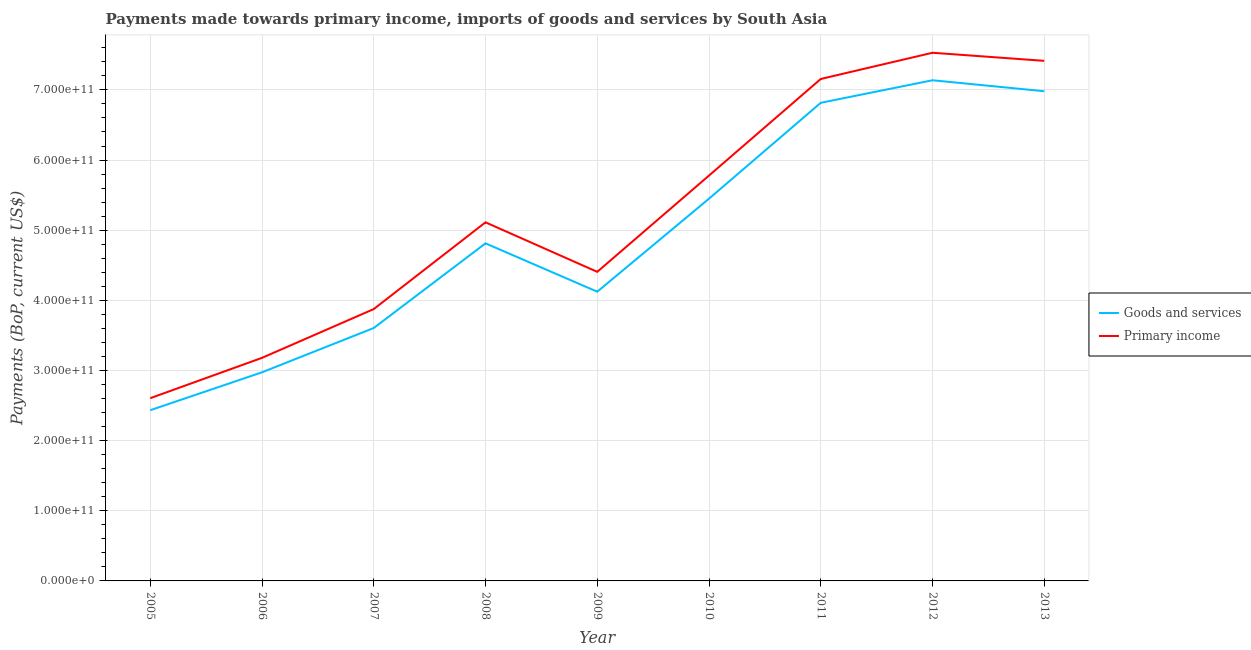How many different coloured lines are there?
Ensure brevity in your answer.  2. Does the line corresponding to payments made towards primary income intersect with the line corresponding to payments made towards goods and services?
Ensure brevity in your answer.  No. Is the number of lines equal to the number of legend labels?
Keep it short and to the point. Yes. What is the payments made towards primary income in 2012?
Your response must be concise. 7.53e+11. Across all years, what is the maximum payments made towards goods and services?
Offer a very short reply. 7.14e+11. Across all years, what is the minimum payments made towards goods and services?
Your answer should be compact. 2.43e+11. In which year was the payments made towards goods and services maximum?
Make the answer very short. 2012. What is the total payments made towards goods and services in the graph?
Keep it short and to the point. 4.43e+12. What is the difference between the payments made towards goods and services in 2009 and that in 2012?
Give a very brief answer. -3.01e+11. What is the difference between the payments made towards primary income in 2013 and the payments made towards goods and services in 2007?
Make the answer very short. 3.81e+11. What is the average payments made towards goods and services per year?
Offer a very short reply. 4.93e+11. In the year 2008, what is the difference between the payments made towards primary income and payments made towards goods and services?
Keep it short and to the point. 3.00e+1. What is the ratio of the payments made towards primary income in 2008 to that in 2009?
Offer a terse response. 1.16. Is the payments made towards primary income in 2006 less than that in 2010?
Give a very brief answer. Yes. Is the difference between the payments made towards goods and services in 2006 and 2008 greater than the difference between the payments made towards primary income in 2006 and 2008?
Keep it short and to the point. Yes. What is the difference between the highest and the second highest payments made towards primary income?
Your answer should be compact. 1.15e+1. What is the difference between the highest and the lowest payments made towards primary income?
Give a very brief answer. 4.92e+11. In how many years, is the payments made towards goods and services greater than the average payments made towards goods and services taken over all years?
Provide a succinct answer. 4. Does the payments made towards primary income monotonically increase over the years?
Provide a succinct answer. No. Is the payments made towards goods and services strictly greater than the payments made towards primary income over the years?
Provide a succinct answer. No. How many lines are there?
Your answer should be compact. 2. How many years are there in the graph?
Provide a short and direct response. 9. What is the difference between two consecutive major ticks on the Y-axis?
Make the answer very short. 1.00e+11. Are the values on the major ticks of Y-axis written in scientific E-notation?
Give a very brief answer. Yes. Does the graph contain any zero values?
Make the answer very short. No. Where does the legend appear in the graph?
Your answer should be compact. Center right. How are the legend labels stacked?
Your answer should be compact. Vertical. What is the title of the graph?
Your answer should be compact. Payments made towards primary income, imports of goods and services by South Asia. What is the label or title of the X-axis?
Give a very brief answer. Year. What is the label or title of the Y-axis?
Provide a succinct answer. Payments (BoP, current US$). What is the Payments (BoP, current US$) of Goods and services in 2005?
Make the answer very short. 2.43e+11. What is the Payments (BoP, current US$) in Primary income in 2005?
Ensure brevity in your answer.  2.61e+11. What is the Payments (BoP, current US$) of Goods and services in 2006?
Provide a short and direct response. 2.97e+11. What is the Payments (BoP, current US$) in Primary income in 2006?
Your answer should be very brief. 3.18e+11. What is the Payments (BoP, current US$) in Goods and services in 2007?
Ensure brevity in your answer.  3.61e+11. What is the Payments (BoP, current US$) in Primary income in 2007?
Your response must be concise. 3.88e+11. What is the Payments (BoP, current US$) in Goods and services in 2008?
Your response must be concise. 4.81e+11. What is the Payments (BoP, current US$) in Primary income in 2008?
Provide a succinct answer. 5.11e+11. What is the Payments (BoP, current US$) in Goods and services in 2009?
Your answer should be compact. 4.12e+11. What is the Payments (BoP, current US$) of Primary income in 2009?
Your answer should be very brief. 4.41e+11. What is the Payments (BoP, current US$) of Goods and services in 2010?
Your response must be concise. 5.45e+11. What is the Payments (BoP, current US$) of Primary income in 2010?
Your answer should be very brief. 5.78e+11. What is the Payments (BoP, current US$) in Goods and services in 2011?
Ensure brevity in your answer.  6.82e+11. What is the Payments (BoP, current US$) in Primary income in 2011?
Keep it short and to the point. 7.16e+11. What is the Payments (BoP, current US$) in Goods and services in 2012?
Your answer should be very brief. 7.14e+11. What is the Payments (BoP, current US$) in Primary income in 2012?
Make the answer very short. 7.53e+11. What is the Payments (BoP, current US$) of Goods and services in 2013?
Ensure brevity in your answer.  6.98e+11. What is the Payments (BoP, current US$) of Primary income in 2013?
Your answer should be very brief. 7.41e+11. Across all years, what is the maximum Payments (BoP, current US$) in Goods and services?
Provide a succinct answer. 7.14e+11. Across all years, what is the maximum Payments (BoP, current US$) of Primary income?
Provide a succinct answer. 7.53e+11. Across all years, what is the minimum Payments (BoP, current US$) in Goods and services?
Make the answer very short. 2.43e+11. Across all years, what is the minimum Payments (BoP, current US$) of Primary income?
Give a very brief answer. 2.61e+11. What is the total Payments (BoP, current US$) of Goods and services in the graph?
Your answer should be very brief. 4.43e+12. What is the total Payments (BoP, current US$) in Primary income in the graph?
Make the answer very short. 4.71e+12. What is the difference between the Payments (BoP, current US$) in Goods and services in 2005 and that in 2006?
Ensure brevity in your answer.  -5.40e+1. What is the difference between the Payments (BoP, current US$) of Primary income in 2005 and that in 2006?
Make the answer very short. -5.75e+1. What is the difference between the Payments (BoP, current US$) of Goods and services in 2005 and that in 2007?
Your answer should be compact. -1.17e+11. What is the difference between the Payments (BoP, current US$) of Primary income in 2005 and that in 2007?
Provide a short and direct response. -1.27e+11. What is the difference between the Payments (BoP, current US$) of Goods and services in 2005 and that in 2008?
Your answer should be very brief. -2.38e+11. What is the difference between the Payments (BoP, current US$) in Primary income in 2005 and that in 2008?
Your answer should be very brief. -2.51e+11. What is the difference between the Payments (BoP, current US$) in Goods and services in 2005 and that in 2009?
Make the answer very short. -1.69e+11. What is the difference between the Payments (BoP, current US$) in Primary income in 2005 and that in 2009?
Provide a succinct answer. -1.80e+11. What is the difference between the Payments (BoP, current US$) in Goods and services in 2005 and that in 2010?
Your answer should be very brief. -3.02e+11. What is the difference between the Payments (BoP, current US$) in Primary income in 2005 and that in 2010?
Your response must be concise. -3.17e+11. What is the difference between the Payments (BoP, current US$) in Goods and services in 2005 and that in 2011?
Your answer should be compact. -4.38e+11. What is the difference between the Payments (BoP, current US$) in Primary income in 2005 and that in 2011?
Provide a short and direct response. -4.55e+11. What is the difference between the Payments (BoP, current US$) in Goods and services in 2005 and that in 2012?
Provide a short and direct response. -4.70e+11. What is the difference between the Payments (BoP, current US$) of Primary income in 2005 and that in 2012?
Your response must be concise. -4.92e+11. What is the difference between the Payments (BoP, current US$) in Goods and services in 2005 and that in 2013?
Provide a succinct answer. -4.55e+11. What is the difference between the Payments (BoP, current US$) of Primary income in 2005 and that in 2013?
Provide a succinct answer. -4.81e+11. What is the difference between the Payments (BoP, current US$) of Goods and services in 2006 and that in 2007?
Your answer should be very brief. -6.32e+1. What is the difference between the Payments (BoP, current US$) of Primary income in 2006 and that in 2007?
Make the answer very short. -6.95e+1. What is the difference between the Payments (BoP, current US$) in Goods and services in 2006 and that in 2008?
Provide a short and direct response. -1.84e+11. What is the difference between the Payments (BoP, current US$) in Primary income in 2006 and that in 2008?
Provide a short and direct response. -1.93e+11. What is the difference between the Payments (BoP, current US$) in Goods and services in 2006 and that in 2009?
Provide a succinct answer. -1.15e+11. What is the difference between the Payments (BoP, current US$) of Primary income in 2006 and that in 2009?
Your answer should be compact. -1.23e+11. What is the difference between the Payments (BoP, current US$) in Goods and services in 2006 and that in 2010?
Your answer should be compact. -2.48e+11. What is the difference between the Payments (BoP, current US$) of Primary income in 2006 and that in 2010?
Give a very brief answer. -2.60e+11. What is the difference between the Payments (BoP, current US$) of Goods and services in 2006 and that in 2011?
Offer a very short reply. -3.84e+11. What is the difference between the Payments (BoP, current US$) in Primary income in 2006 and that in 2011?
Your answer should be very brief. -3.98e+11. What is the difference between the Payments (BoP, current US$) in Goods and services in 2006 and that in 2012?
Provide a succinct answer. -4.16e+11. What is the difference between the Payments (BoP, current US$) of Primary income in 2006 and that in 2012?
Provide a short and direct response. -4.35e+11. What is the difference between the Payments (BoP, current US$) in Goods and services in 2006 and that in 2013?
Make the answer very short. -4.01e+11. What is the difference between the Payments (BoP, current US$) of Primary income in 2006 and that in 2013?
Keep it short and to the point. -4.23e+11. What is the difference between the Payments (BoP, current US$) in Goods and services in 2007 and that in 2008?
Provide a succinct answer. -1.21e+11. What is the difference between the Payments (BoP, current US$) in Primary income in 2007 and that in 2008?
Provide a short and direct response. -1.24e+11. What is the difference between the Payments (BoP, current US$) in Goods and services in 2007 and that in 2009?
Offer a terse response. -5.18e+1. What is the difference between the Payments (BoP, current US$) of Primary income in 2007 and that in 2009?
Ensure brevity in your answer.  -5.31e+1. What is the difference between the Payments (BoP, current US$) in Goods and services in 2007 and that in 2010?
Your response must be concise. -1.84e+11. What is the difference between the Payments (BoP, current US$) in Primary income in 2007 and that in 2010?
Ensure brevity in your answer.  -1.90e+11. What is the difference between the Payments (BoP, current US$) of Goods and services in 2007 and that in 2011?
Provide a short and direct response. -3.21e+11. What is the difference between the Payments (BoP, current US$) in Primary income in 2007 and that in 2011?
Offer a very short reply. -3.28e+11. What is the difference between the Payments (BoP, current US$) of Goods and services in 2007 and that in 2012?
Ensure brevity in your answer.  -3.53e+11. What is the difference between the Payments (BoP, current US$) in Primary income in 2007 and that in 2012?
Make the answer very short. -3.65e+11. What is the difference between the Payments (BoP, current US$) of Goods and services in 2007 and that in 2013?
Ensure brevity in your answer.  -3.38e+11. What is the difference between the Payments (BoP, current US$) in Primary income in 2007 and that in 2013?
Give a very brief answer. -3.54e+11. What is the difference between the Payments (BoP, current US$) in Goods and services in 2008 and that in 2009?
Make the answer very short. 6.89e+1. What is the difference between the Payments (BoP, current US$) in Primary income in 2008 and that in 2009?
Give a very brief answer. 7.06e+1. What is the difference between the Payments (BoP, current US$) in Goods and services in 2008 and that in 2010?
Keep it short and to the point. -6.37e+1. What is the difference between the Payments (BoP, current US$) in Primary income in 2008 and that in 2010?
Offer a terse response. -6.66e+1. What is the difference between the Payments (BoP, current US$) of Goods and services in 2008 and that in 2011?
Your answer should be compact. -2.00e+11. What is the difference between the Payments (BoP, current US$) in Primary income in 2008 and that in 2011?
Give a very brief answer. -2.04e+11. What is the difference between the Payments (BoP, current US$) of Goods and services in 2008 and that in 2012?
Your answer should be very brief. -2.33e+11. What is the difference between the Payments (BoP, current US$) of Primary income in 2008 and that in 2012?
Make the answer very short. -2.42e+11. What is the difference between the Payments (BoP, current US$) of Goods and services in 2008 and that in 2013?
Your response must be concise. -2.17e+11. What is the difference between the Payments (BoP, current US$) of Primary income in 2008 and that in 2013?
Give a very brief answer. -2.30e+11. What is the difference between the Payments (BoP, current US$) in Goods and services in 2009 and that in 2010?
Ensure brevity in your answer.  -1.33e+11. What is the difference between the Payments (BoP, current US$) in Primary income in 2009 and that in 2010?
Your response must be concise. -1.37e+11. What is the difference between the Payments (BoP, current US$) of Goods and services in 2009 and that in 2011?
Your response must be concise. -2.69e+11. What is the difference between the Payments (BoP, current US$) of Primary income in 2009 and that in 2011?
Give a very brief answer. -2.75e+11. What is the difference between the Payments (BoP, current US$) of Goods and services in 2009 and that in 2012?
Provide a short and direct response. -3.01e+11. What is the difference between the Payments (BoP, current US$) of Primary income in 2009 and that in 2012?
Make the answer very short. -3.12e+11. What is the difference between the Payments (BoP, current US$) of Goods and services in 2009 and that in 2013?
Your answer should be very brief. -2.86e+11. What is the difference between the Payments (BoP, current US$) in Primary income in 2009 and that in 2013?
Provide a succinct answer. -3.01e+11. What is the difference between the Payments (BoP, current US$) of Goods and services in 2010 and that in 2011?
Offer a terse response. -1.37e+11. What is the difference between the Payments (BoP, current US$) of Primary income in 2010 and that in 2011?
Offer a very short reply. -1.38e+11. What is the difference between the Payments (BoP, current US$) in Goods and services in 2010 and that in 2012?
Keep it short and to the point. -1.69e+11. What is the difference between the Payments (BoP, current US$) in Primary income in 2010 and that in 2012?
Provide a succinct answer. -1.75e+11. What is the difference between the Payments (BoP, current US$) in Goods and services in 2010 and that in 2013?
Your answer should be very brief. -1.53e+11. What is the difference between the Payments (BoP, current US$) of Primary income in 2010 and that in 2013?
Ensure brevity in your answer.  -1.64e+11. What is the difference between the Payments (BoP, current US$) of Goods and services in 2011 and that in 2012?
Give a very brief answer. -3.21e+1. What is the difference between the Payments (BoP, current US$) in Primary income in 2011 and that in 2012?
Give a very brief answer. -3.74e+1. What is the difference between the Payments (BoP, current US$) in Goods and services in 2011 and that in 2013?
Your response must be concise. -1.65e+1. What is the difference between the Payments (BoP, current US$) of Primary income in 2011 and that in 2013?
Your response must be concise. -2.58e+1. What is the difference between the Payments (BoP, current US$) of Goods and services in 2012 and that in 2013?
Your answer should be compact. 1.56e+1. What is the difference between the Payments (BoP, current US$) in Primary income in 2012 and that in 2013?
Offer a terse response. 1.15e+1. What is the difference between the Payments (BoP, current US$) in Goods and services in 2005 and the Payments (BoP, current US$) in Primary income in 2006?
Provide a succinct answer. -7.46e+1. What is the difference between the Payments (BoP, current US$) of Goods and services in 2005 and the Payments (BoP, current US$) of Primary income in 2007?
Offer a very short reply. -1.44e+11. What is the difference between the Payments (BoP, current US$) of Goods and services in 2005 and the Payments (BoP, current US$) of Primary income in 2008?
Your response must be concise. -2.68e+11. What is the difference between the Payments (BoP, current US$) of Goods and services in 2005 and the Payments (BoP, current US$) of Primary income in 2009?
Offer a very short reply. -1.97e+11. What is the difference between the Payments (BoP, current US$) of Goods and services in 2005 and the Payments (BoP, current US$) of Primary income in 2010?
Provide a succinct answer. -3.34e+11. What is the difference between the Payments (BoP, current US$) in Goods and services in 2005 and the Payments (BoP, current US$) in Primary income in 2011?
Provide a short and direct response. -4.72e+11. What is the difference between the Payments (BoP, current US$) of Goods and services in 2005 and the Payments (BoP, current US$) of Primary income in 2012?
Keep it short and to the point. -5.10e+11. What is the difference between the Payments (BoP, current US$) of Goods and services in 2005 and the Payments (BoP, current US$) of Primary income in 2013?
Provide a succinct answer. -4.98e+11. What is the difference between the Payments (BoP, current US$) in Goods and services in 2006 and the Payments (BoP, current US$) in Primary income in 2007?
Make the answer very short. -9.01e+1. What is the difference between the Payments (BoP, current US$) in Goods and services in 2006 and the Payments (BoP, current US$) in Primary income in 2008?
Provide a short and direct response. -2.14e+11. What is the difference between the Payments (BoP, current US$) of Goods and services in 2006 and the Payments (BoP, current US$) of Primary income in 2009?
Offer a terse response. -1.43e+11. What is the difference between the Payments (BoP, current US$) of Goods and services in 2006 and the Payments (BoP, current US$) of Primary income in 2010?
Make the answer very short. -2.80e+11. What is the difference between the Payments (BoP, current US$) of Goods and services in 2006 and the Payments (BoP, current US$) of Primary income in 2011?
Ensure brevity in your answer.  -4.18e+11. What is the difference between the Payments (BoP, current US$) in Goods and services in 2006 and the Payments (BoP, current US$) in Primary income in 2012?
Ensure brevity in your answer.  -4.56e+11. What is the difference between the Payments (BoP, current US$) of Goods and services in 2006 and the Payments (BoP, current US$) of Primary income in 2013?
Provide a succinct answer. -4.44e+11. What is the difference between the Payments (BoP, current US$) in Goods and services in 2007 and the Payments (BoP, current US$) in Primary income in 2008?
Your response must be concise. -1.51e+11. What is the difference between the Payments (BoP, current US$) in Goods and services in 2007 and the Payments (BoP, current US$) in Primary income in 2009?
Offer a very short reply. -8.01e+1. What is the difference between the Payments (BoP, current US$) in Goods and services in 2007 and the Payments (BoP, current US$) in Primary income in 2010?
Provide a short and direct response. -2.17e+11. What is the difference between the Payments (BoP, current US$) of Goods and services in 2007 and the Payments (BoP, current US$) of Primary income in 2011?
Make the answer very short. -3.55e+11. What is the difference between the Payments (BoP, current US$) of Goods and services in 2007 and the Payments (BoP, current US$) of Primary income in 2012?
Provide a succinct answer. -3.92e+11. What is the difference between the Payments (BoP, current US$) of Goods and services in 2007 and the Payments (BoP, current US$) of Primary income in 2013?
Make the answer very short. -3.81e+11. What is the difference between the Payments (BoP, current US$) in Goods and services in 2008 and the Payments (BoP, current US$) in Primary income in 2009?
Your response must be concise. 4.06e+1. What is the difference between the Payments (BoP, current US$) in Goods and services in 2008 and the Payments (BoP, current US$) in Primary income in 2010?
Your response must be concise. -9.66e+1. What is the difference between the Payments (BoP, current US$) in Goods and services in 2008 and the Payments (BoP, current US$) in Primary income in 2011?
Provide a succinct answer. -2.34e+11. What is the difference between the Payments (BoP, current US$) of Goods and services in 2008 and the Payments (BoP, current US$) of Primary income in 2012?
Your response must be concise. -2.72e+11. What is the difference between the Payments (BoP, current US$) of Goods and services in 2008 and the Payments (BoP, current US$) of Primary income in 2013?
Make the answer very short. -2.60e+11. What is the difference between the Payments (BoP, current US$) in Goods and services in 2009 and the Payments (BoP, current US$) in Primary income in 2010?
Your answer should be compact. -1.66e+11. What is the difference between the Payments (BoP, current US$) of Goods and services in 2009 and the Payments (BoP, current US$) of Primary income in 2011?
Your response must be concise. -3.03e+11. What is the difference between the Payments (BoP, current US$) of Goods and services in 2009 and the Payments (BoP, current US$) of Primary income in 2012?
Your answer should be very brief. -3.41e+11. What is the difference between the Payments (BoP, current US$) in Goods and services in 2009 and the Payments (BoP, current US$) in Primary income in 2013?
Offer a very short reply. -3.29e+11. What is the difference between the Payments (BoP, current US$) in Goods and services in 2010 and the Payments (BoP, current US$) in Primary income in 2011?
Ensure brevity in your answer.  -1.71e+11. What is the difference between the Payments (BoP, current US$) of Goods and services in 2010 and the Payments (BoP, current US$) of Primary income in 2012?
Your answer should be very brief. -2.08e+11. What is the difference between the Payments (BoP, current US$) of Goods and services in 2010 and the Payments (BoP, current US$) of Primary income in 2013?
Your answer should be very brief. -1.96e+11. What is the difference between the Payments (BoP, current US$) in Goods and services in 2011 and the Payments (BoP, current US$) in Primary income in 2012?
Offer a terse response. -7.14e+1. What is the difference between the Payments (BoP, current US$) in Goods and services in 2011 and the Payments (BoP, current US$) in Primary income in 2013?
Provide a short and direct response. -5.98e+1. What is the difference between the Payments (BoP, current US$) in Goods and services in 2012 and the Payments (BoP, current US$) in Primary income in 2013?
Your answer should be very brief. -2.77e+1. What is the average Payments (BoP, current US$) in Goods and services per year?
Give a very brief answer. 4.93e+11. What is the average Payments (BoP, current US$) of Primary income per year?
Give a very brief answer. 5.23e+11. In the year 2005, what is the difference between the Payments (BoP, current US$) in Goods and services and Payments (BoP, current US$) in Primary income?
Ensure brevity in your answer.  -1.71e+1. In the year 2006, what is the difference between the Payments (BoP, current US$) in Goods and services and Payments (BoP, current US$) in Primary income?
Provide a succinct answer. -2.06e+1. In the year 2007, what is the difference between the Payments (BoP, current US$) of Goods and services and Payments (BoP, current US$) of Primary income?
Your response must be concise. -2.70e+1. In the year 2008, what is the difference between the Payments (BoP, current US$) of Goods and services and Payments (BoP, current US$) of Primary income?
Your response must be concise. -3.00e+1. In the year 2009, what is the difference between the Payments (BoP, current US$) of Goods and services and Payments (BoP, current US$) of Primary income?
Give a very brief answer. -2.83e+1. In the year 2010, what is the difference between the Payments (BoP, current US$) in Goods and services and Payments (BoP, current US$) in Primary income?
Make the answer very short. -3.30e+1. In the year 2011, what is the difference between the Payments (BoP, current US$) of Goods and services and Payments (BoP, current US$) of Primary income?
Your response must be concise. -3.40e+1. In the year 2012, what is the difference between the Payments (BoP, current US$) of Goods and services and Payments (BoP, current US$) of Primary income?
Provide a succinct answer. -3.92e+1. In the year 2013, what is the difference between the Payments (BoP, current US$) in Goods and services and Payments (BoP, current US$) in Primary income?
Give a very brief answer. -4.33e+1. What is the ratio of the Payments (BoP, current US$) of Goods and services in 2005 to that in 2006?
Give a very brief answer. 0.82. What is the ratio of the Payments (BoP, current US$) in Primary income in 2005 to that in 2006?
Your answer should be compact. 0.82. What is the ratio of the Payments (BoP, current US$) of Goods and services in 2005 to that in 2007?
Provide a succinct answer. 0.68. What is the ratio of the Payments (BoP, current US$) in Primary income in 2005 to that in 2007?
Provide a short and direct response. 0.67. What is the ratio of the Payments (BoP, current US$) in Goods and services in 2005 to that in 2008?
Provide a short and direct response. 0.51. What is the ratio of the Payments (BoP, current US$) in Primary income in 2005 to that in 2008?
Give a very brief answer. 0.51. What is the ratio of the Payments (BoP, current US$) in Goods and services in 2005 to that in 2009?
Offer a very short reply. 0.59. What is the ratio of the Payments (BoP, current US$) in Primary income in 2005 to that in 2009?
Provide a succinct answer. 0.59. What is the ratio of the Payments (BoP, current US$) in Goods and services in 2005 to that in 2010?
Give a very brief answer. 0.45. What is the ratio of the Payments (BoP, current US$) of Primary income in 2005 to that in 2010?
Make the answer very short. 0.45. What is the ratio of the Payments (BoP, current US$) in Goods and services in 2005 to that in 2011?
Your answer should be compact. 0.36. What is the ratio of the Payments (BoP, current US$) of Primary income in 2005 to that in 2011?
Offer a very short reply. 0.36. What is the ratio of the Payments (BoP, current US$) in Goods and services in 2005 to that in 2012?
Keep it short and to the point. 0.34. What is the ratio of the Payments (BoP, current US$) in Primary income in 2005 to that in 2012?
Keep it short and to the point. 0.35. What is the ratio of the Payments (BoP, current US$) of Goods and services in 2005 to that in 2013?
Your answer should be very brief. 0.35. What is the ratio of the Payments (BoP, current US$) of Primary income in 2005 to that in 2013?
Make the answer very short. 0.35. What is the ratio of the Payments (BoP, current US$) in Goods and services in 2006 to that in 2007?
Offer a very short reply. 0.82. What is the ratio of the Payments (BoP, current US$) of Primary income in 2006 to that in 2007?
Offer a very short reply. 0.82. What is the ratio of the Payments (BoP, current US$) in Goods and services in 2006 to that in 2008?
Give a very brief answer. 0.62. What is the ratio of the Payments (BoP, current US$) of Primary income in 2006 to that in 2008?
Give a very brief answer. 0.62. What is the ratio of the Payments (BoP, current US$) in Goods and services in 2006 to that in 2009?
Ensure brevity in your answer.  0.72. What is the ratio of the Payments (BoP, current US$) of Primary income in 2006 to that in 2009?
Ensure brevity in your answer.  0.72. What is the ratio of the Payments (BoP, current US$) in Goods and services in 2006 to that in 2010?
Keep it short and to the point. 0.55. What is the ratio of the Payments (BoP, current US$) in Primary income in 2006 to that in 2010?
Provide a succinct answer. 0.55. What is the ratio of the Payments (BoP, current US$) of Goods and services in 2006 to that in 2011?
Keep it short and to the point. 0.44. What is the ratio of the Payments (BoP, current US$) of Primary income in 2006 to that in 2011?
Provide a succinct answer. 0.44. What is the ratio of the Payments (BoP, current US$) of Goods and services in 2006 to that in 2012?
Your response must be concise. 0.42. What is the ratio of the Payments (BoP, current US$) in Primary income in 2006 to that in 2012?
Your answer should be very brief. 0.42. What is the ratio of the Payments (BoP, current US$) of Goods and services in 2006 to that in 2013?
Your answer should be very brief. 0.43. What is the ratio of the Payments (BoP, current US$) of Primary income in 2006 to that in 2013?
Provide a short and direct response. 0.43. What is the ratio of the Payments (BoP, current US$) in Goods and services in 2007 to that in 2008?
Your response must be concise. 0.75. What is the ratio of the Payments (BoP, current US$) of Primary income in 2007 to that in 2008?
Give a very brief answer. 0.76. What is the ratio of the Payments (BoP, current US$) of Goods and services in 2007 to that in 2009?
Make the answer very short. 0.87. What is the ratio of the Payments (BoP, current US$) of Primary income in 2007 to that in 2009?
Your answer should be compact. 0.88. What is the ratio of the Payments (BoP, current US$) in Goods and services in 2007 to that in 2010?
Provide a succinct answer. 0.66. What is the ratio of the Payments (BoP, current US$) in Primary income in 2007 to that in 2010?
Provide a short and direct response. 0.67. What is the ratio of the Payments (BoP, current US$) of Goods and services in 2007 to that in 2011?
Offer a terse response. 0.53. What is the ratio of the Payments (BoP, current US$) in Primary income in 2007 to that in 2011?
Keep it short and to the point. 0.54. What is the ratio of the Payments (BoP, current US$) of Goods and services in 2007 to that in 2012?
Your answer should be very brief. 0.51. What is the ratio of the Payments (BoP, current US$) in Primary income in 2007 to that in 2012?
Ensure brevity in your answer.  0.51. What is the ratio of the Payments (BoP, current US$) of Goods and services in 2007 to that in 2013?
Your answer should be compact. 0.52. What is the ratio of the Payments (BoP, current US$) of Primary income in 2007 to that in 2013?
Offer a terse response. 0.52. What is the ratio of the Payments (BoP, current US$) in Goods and services in 2008 to that in 2009?
Provide a short and direct response. 1.17. What is the ratio of the Payments (BoP, current US$) in Primary income in 2008 to that in 2009?
Provide a short and direct response. 1.16. What is the ratio of the Payments (BoP, current US$) of Goods and services in 2008 to that in 2010?
Provide a succinct answer. 0.88. What is the ratio of the Payments (BoP, current US$) of Primary income in 2008 to that in 2010?
Offer a terse response. 0.88. What is the ratio of the Payments (BoP, current US$) of Goods and services in 2008 to that in 2011?
Your answer should be compact. 0.71. What is the ratio of the Payments (BoP, current US$) of Primary income in 2008 to that in 2011?
Your answer should be very brief. 0.71. What is the ratio of the Payments (BoP, current US$) of Goods and services in 2008 to that in 2012?
Ensure brevity in your answer.  0.67. What is the ratio of the Payments (BoP, current US$) of Primary income in 2008 to that in 2012?
Keep it short and to the point. 0.68. What is the ratio of the Payments (BoP, current US$) in Goods and services in 2008 to that in 2013?
Offer a terse response. 0.69. What is the ratio of the Payments (BoP, current US$) of Primary income in 2008 to that in 2013?
Give a very brief answer. 0.69. What is the ratio of the Payments (BoP, current US$) in Goods and services in 2009 to that in 2010?
Your answer should be very brief. 0.76. What is the ratio of the Payments (BoP, current US$) in Primary income in 2009 to that in 2010?
Offer a very short reply. 0.76. What is the ratio of the Payments (BoP, current US$) in Goods and services in 2009 to that in 2011?
Offer a very short reply. 0.6. What is the ratio of the Payments (BoP, current US$) in Primary income in 2009 to that in 2011?
Your response must be concise. 0.62. What is the ratio of the Payments (BoP, current US$) in Goods and services in 2009 to that in 2012?
Your answer should be very brief. 0.58. What is the ratio of the Payments (BoP, current US$) in Primary income in 2009 to that in 2012?
Your response must be concise. 0.59. What is the ratio of the Payments (BoP, current US$) of Goods and services in 2009 to that in 2013?
Give a very brief answer. 0.59. What is the ratio of the Payments (BoP, current US$) of Primary income in 2009 to that in 2013?
Offer a terse response. 0.59. What is the ratio of the Payments (BoP, current US$) in Goods and services in 2010 to that in 2011?
Offer a very short reply. 0.8. What is the ratio of the Payments (BoP, current US$) in Primary income in 2010 to that in 2011?
Your answer should be compact. 0.81. What is the ratio of the Payments (BoP, current US$) of Goods and services in 2010 to that in 2012?
Your response must be concise. 0.76. What is the ratio of the Payments (BoP, current US$) in Primary income in 2010 to that in 2012?
Provide a succinct answer. 0.77. What is the ratio of the Payments (BoP, current US$) of Goods and services in 2010 to that in 2013?
Provide a succinct answer. 0.78. What is the ratio of the Payments (BoP, current US$) in Primary income in 2010 to that in 2013?
Your answer should be compact. 0.78. What is the ratio of the Payments (BoP, current US$) of Goods and services in 2011 to that in 2012?
Provide a short and direct response. 0.95. What is the ratio of the Payments (BoP, current US$) of Primary income in 2011 to that in 2012?
Offer a very short reply. 0.95. What is the ratio of the Payments (BoP, current US$) in Goods and services in 2011 to that in 2013?
Provide a succinct answer. 0.98. What is the ratio of the Payments (BoP, current US$) of Primary income in 2011 to that in 2013?
Your answer should be very brief. 0.97. What is the ratio of the Payments (BoP, current US$) of Goods and services in 2012 to that in 2013?
Ensure brevity in your answer.  1.02. What is the ratio of the Payments (BoP, current US$) of Primary income in 2012 to that in 2013?
Provide a succinct answer. 1.02. What is the difference between the highest and the second highest Payments (BoP, current US$) in Goods and services?
Provide a succinct answer. 1.56e+1. What is the difference between the highest and the second highest Payments (BoP, current US$) in Primary income?
Your response must be concise. 1.15e+1. What is the difference between the highest and the lowest Payments (BoP, current US$) in Goods and services?
Give a very brief answer. 4.70e+11. What is the difference between the highest and the lowest Payments (BoP, current US$) in Primary income?
Your answer should be very brief. 4.92e+11. 